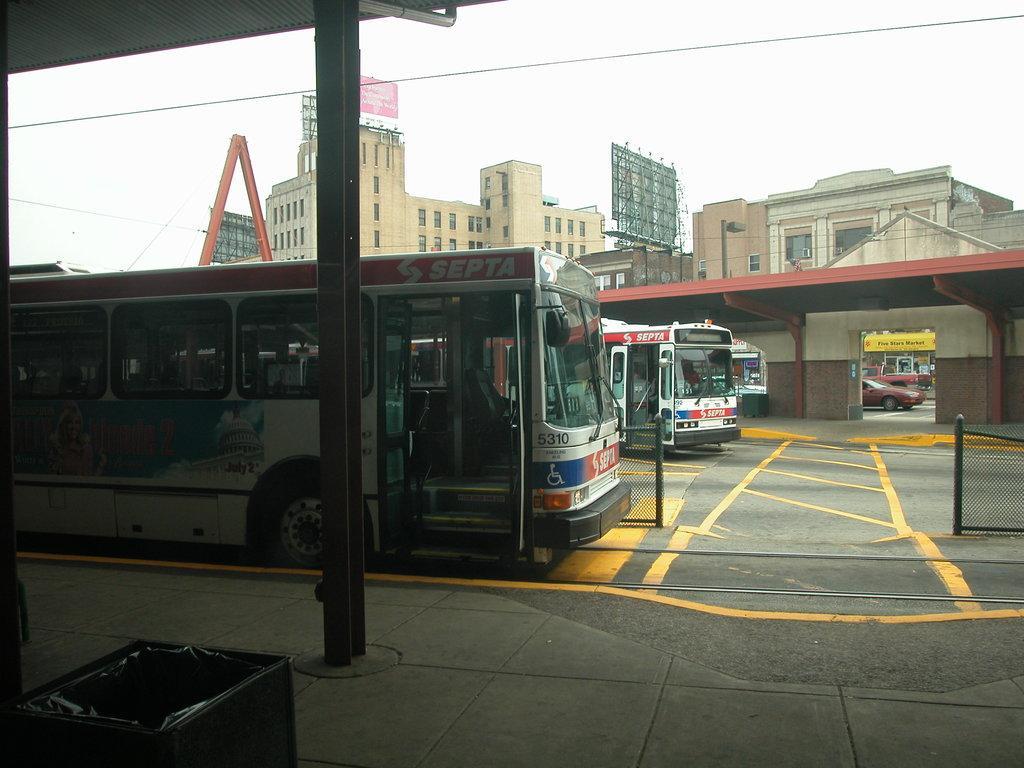Could you give a brief overview of what you see in this image? In this picture we can see a place where we have some buses and to the side we can see some sheds, behind we can see some buildings. 